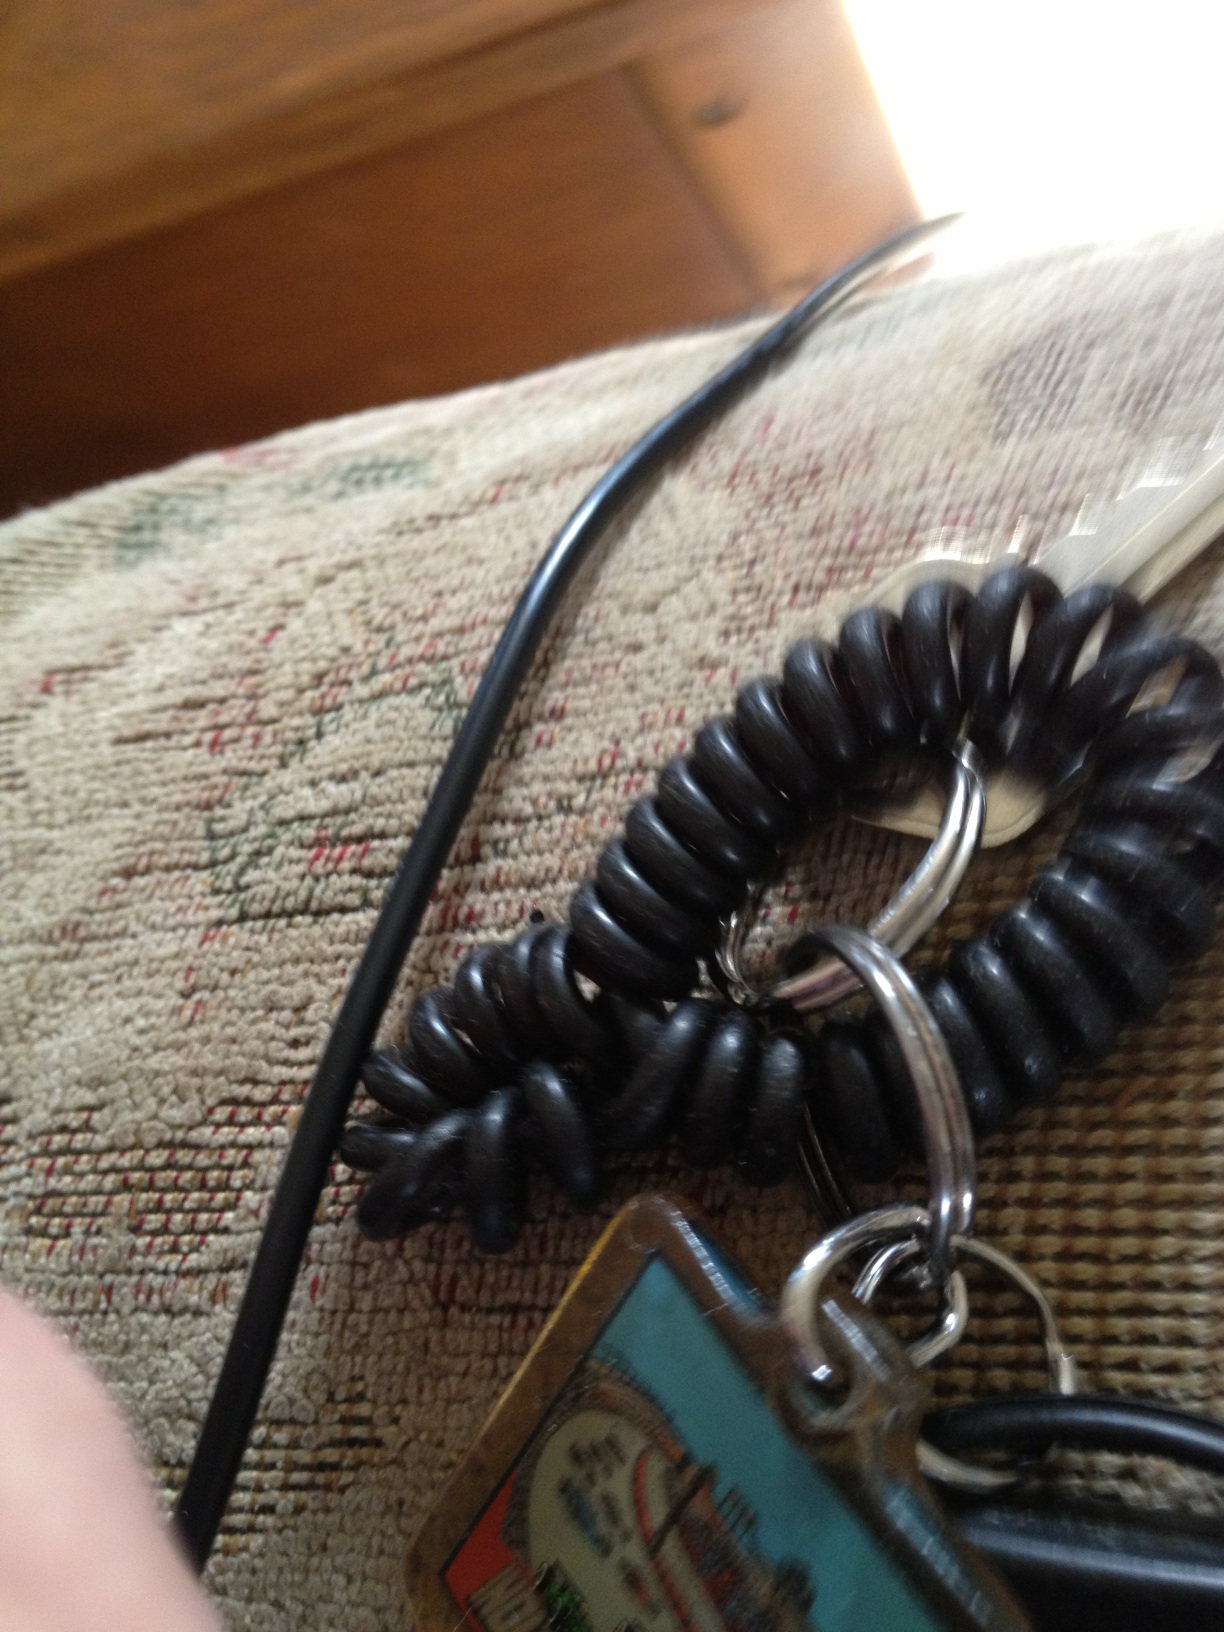What is this item? This appears to be a keychain, which is used to hold keys together and often includes a decorative or identifying element. 